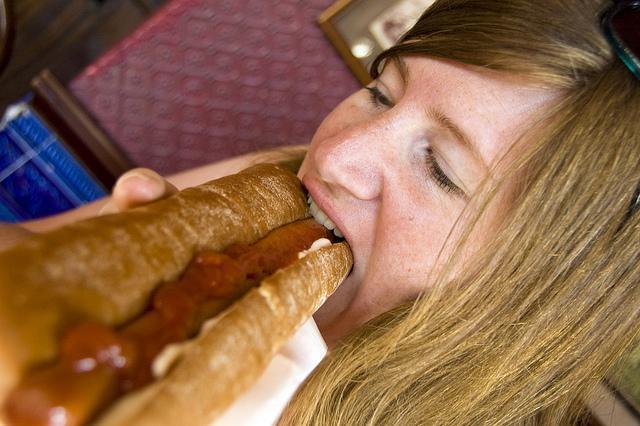How many hot dog buns are in the picture?
Give a very brief answer. 1. How many different trains are there?
Give a very brief answer. 0. 